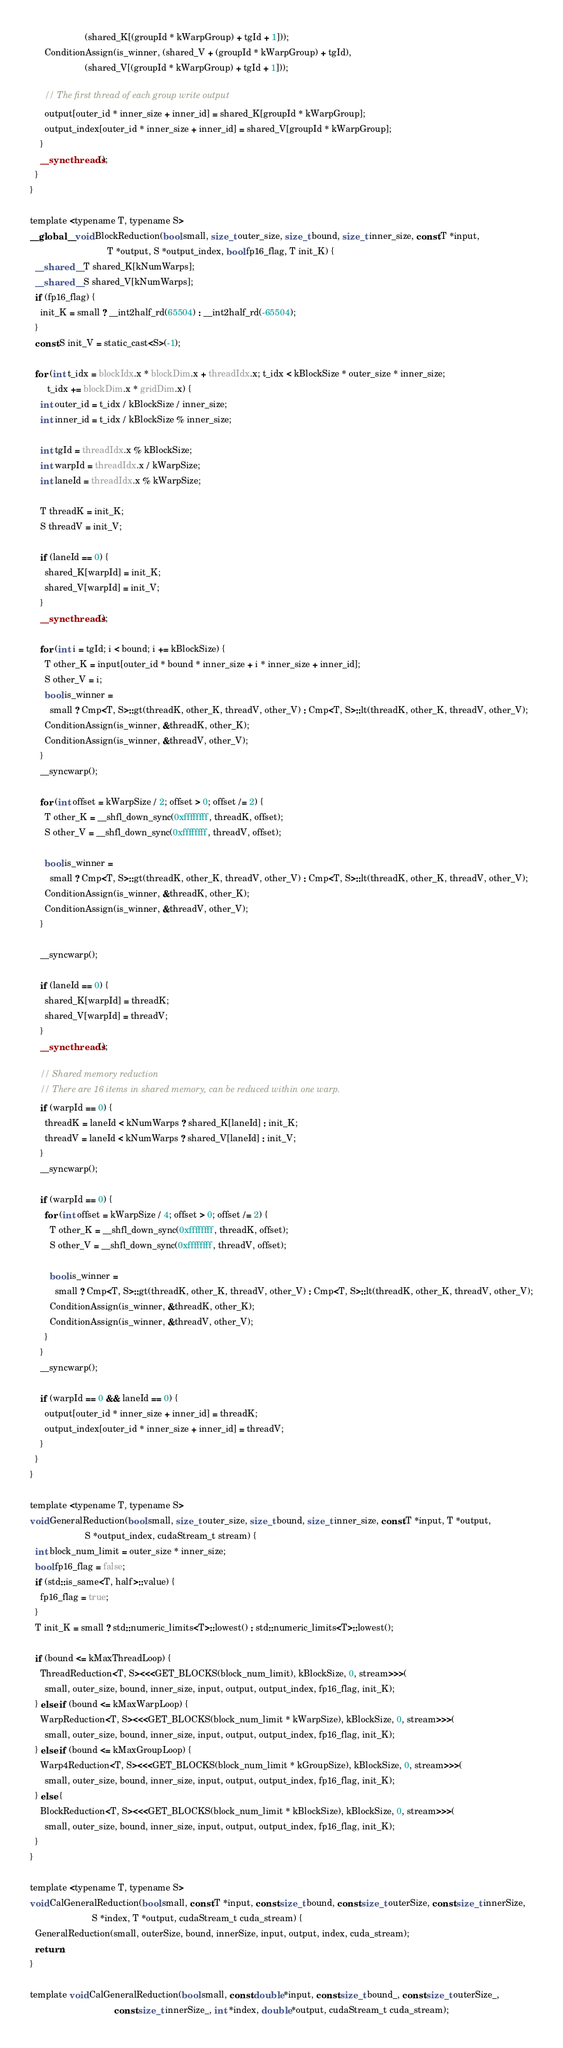<code> <loc_0><loc_0><loc_500><loc_500><_Cuda_>                      (shared_K[(groupId * kWarpGroup) + tgId + 1]));
      ConditionAssign(is_winner, (shared_V + (groupId * kWarpGroup) + tgId),
                      (shared_V[(groupId * kWarpGroup) + tgId + 1]));

      // The first thread of each group write output
      output[outer_id * inner_size + inner_id] = shared_K[groupId * kWarpGroup];
      output_index[outer_id * inner_size + inner_id] = shared_V[groupId * kWarpGroup];
    }
    __syncthreads();
  }
}

template <typename T, typename S>
__global__ void BlockReduction(bool small, size_t outer_size, size_t bound, size_t inner_size, const T *input,
                               T *output, S *output_index, bool fp16_flag, T init_K) {
  __shared__ T shared_K[kNumWarps];
  __shared__ S shared_V[kNumWarps];
  if (fp16_flag) {
    init_K = small ? __int2half_rd(65504) : __int2half_rd(-65504);
  }
  const S init_V = static_cast<S>(-1);

  for (int t_idx = blockIdx.x * blockDim.x + threadIdx.x; t_idx < kBlockSize * outer_size * inner_size;
       t_idx += blockDim.x * gridDim.x) {
    int outer_id = t_idx / kBlockSize / inner_size;
    int inner_id = t_idx / kBlockSize % inner_size;

    int tgId = threadIdx.x % kBlockSize;
    int warpId = threadIdx.x / kWarpSize;
    int laneId = threadIdx.x % kWarpSize;

    T threadK = init_K;
    S threadV = init_V;

    if (laneId == 0) {
      shared_K[warpId] = init_K;
      shared_V[warpId] = init_V;
    }
    __syncthreads();

    for (int i = tgId; i < bound; i += kBlockSize) {
      T other_K = input[outer_id * bound * inner_size + i * inner_size + inner_id];
      S other_V = i;
      bool is_winner =
        small ? Cmp<T, S>::gt(threadK, other_K, threadV, other_V) : Cmp<T, S>::lt(threadK, other_K, threadV, other_V);
      ConditionAssign(is_winner, &threadK, other_K);
      ConditionAssign(is_winner, &threadV, other_V);
    }
    __syncwarp();

    for (int offset = kWarpSize / 2; offset > 0; offset /= 2) {
      T other_K = __shfl_down_sync(0xffffffff, threadK, offset);
      S other_V = __shfl_down_sync(0xffffffff, threadV, offset);

      bool is_winner =
        small ? Cmp<T, S>::gt(threadK, other_K, threadV, other_V) : Cmp<T, S>::lt(threadK, other_K, threadV, other_V);
      ConditionAssign(is_winner, &threadK, other_K);
      ConditionAssign(is_winner, &threadV, other_V);
    }

    __syncwarp();

    if (laneId == 0) {
      shared_K[warpId] = threadK;
      shared_V[warpId] = threadV;
    }
    __syncthreads();

    // Shared memory reduction
    // There are 16 items in shared memory, can be reduced within one warp.
    if (warpId == 0) {
      threadK = laneId < kNumWarps ? shared_K[laneId] : init_K;
      threadV = laneId < kNumWarps ? shared_V[laneId] : init_V;
    }
    __syncwarp();

    if (warpId == 0) {
      for (int offset = kWarpSize / 4; offset > 0; offset /= 2) {
        T other_K = __shfl_down_sync(0xffffffff, threadK, offset);
        S other_V = __shfl_down_sync(0xffffffff, threadV, offset);

        bool is_winner =
          small ? Cmp<T, S>::gt(threadK, other_K, threadV, other_V) : Cmp<T, S>::lt(threadK, other_K, threadV, other_V);
        ConditionAssign(is_winner, &threadK, other_K);
        ConditionAssign(is_winner, &threadV, other_V);
      }
    }
    __syncwarp();

    if (warpId == 0 && laneId == 0) {
      output[outer_id * inner_size + inner_id] = threadK;
      output_index[outer_id * inner_size + inner_id] = threadV;
    }
  }
}

template <typename T, typename S>
void GeneralReduction(bool small, size_t outer_size, size_t bound, size_t inner_size, const T *input, T *output,
                      S *output_index, cudaStream_t stream) {
  int block_num_limit = outer_size * inner_size;
  bool fp16_flag = false;
  if (std::is_same<T, half>::value) {
    fp16_flag = true;
  }
  T init_K = small ? std::numeric_limits<T>::lowest() : std::numeric_limits<T>::lowest();

  if (bound <= kMaxThreadLoop) {
    ThreadReduction<T, S><<<GET_BLOCKS(block_num_limit), kBlockSize, 0, stream>>>(
      small, outer_size, bound, inner_size, input, output, output_index, fp16_flag, init_K);
  } else if (bound <= kMaxWarpLoop) {
    WarpReduction<T, S><<<GET_BLOCKS(block_num_limit * kWarpSize), kBlockSize, 0, stream>>>(
      small, outer_size, bound, inner_size, input, output, output_index, fp16_flag, init_K);
  } else if (bound <= kMaxGroupLoop) {
    Warp4Reduction<T, S><<<GET_BLOCKS(block_num_limit * kGroupSize), kBlockSize, 0, stream>>>(
      small, outer_size, bound, inner_size, input, output, output_index, fp16_flag, init_K);
  } else {
    BlockReduction<T, S><<<GET_BLOCKS(block_num_limit * kBlockSize), kBlockSize, 0, stream>>>(
      small, outer_size, bound, inner_size, input, output, output_index, fp16_flag, init_K);
  }
}

template <typename T, typename S>
void CalGeneralReduction(bool small, const T *input, const size_t bound, const size_t outerSize, const size_t innerSize,
                         S *index, T *output, cudaStream_t cuda_stream) {
  GeneralReduction(small, outerSize, bound, innerSize, input, output, index, cuda_stream);
  return;
}

template void CalGeneralReduction(bool small, const double *input, const size_t bound_, const size_t outerSize_,
                                  const size_t innerSize_, int *index, double *output, cudaStream_t cuda_stream);</code> 